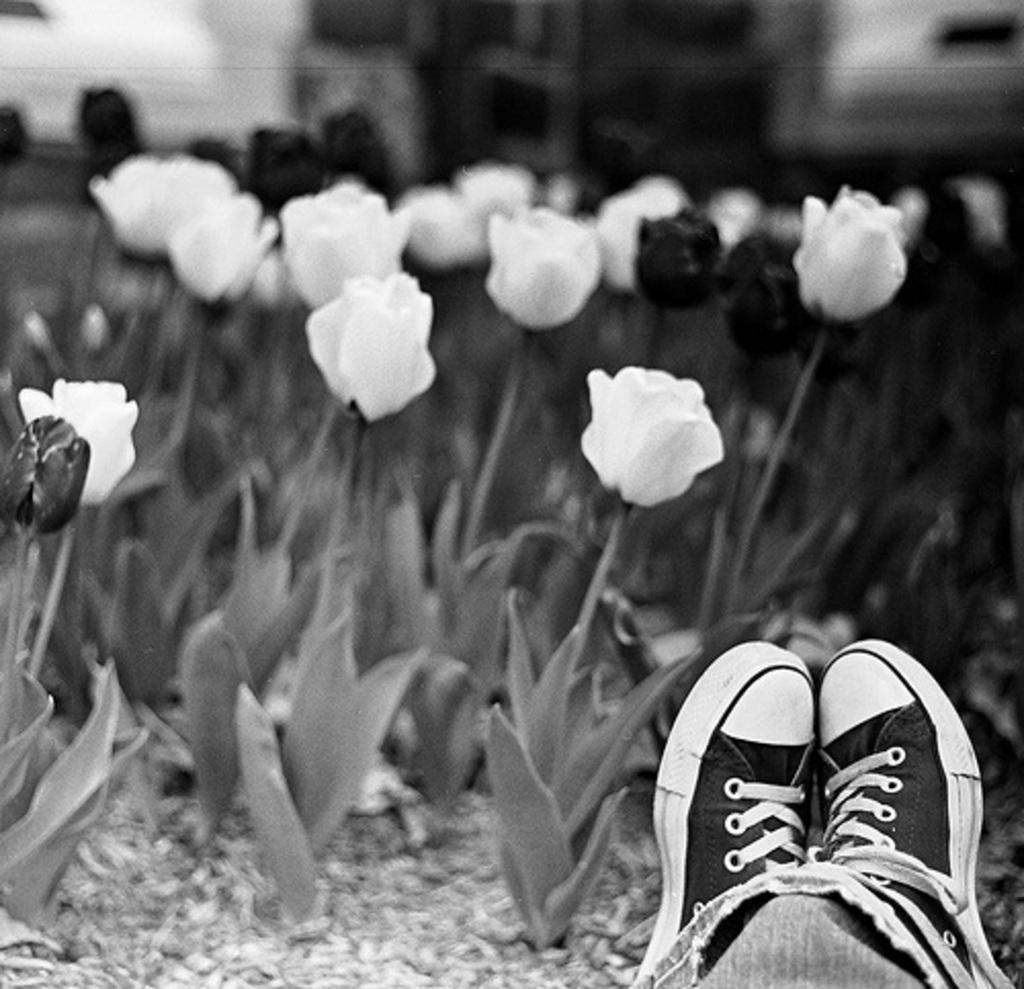What type of plants can be seen in the image? There are flowers in the image. Where are the shoes located in the image? The shoes are in the bottom right corner of the image. What type of song can be heard coming from the giraffe in the image? There is no giraffe present in the image, so it's not possible to determine what, if any, song might be heard. 